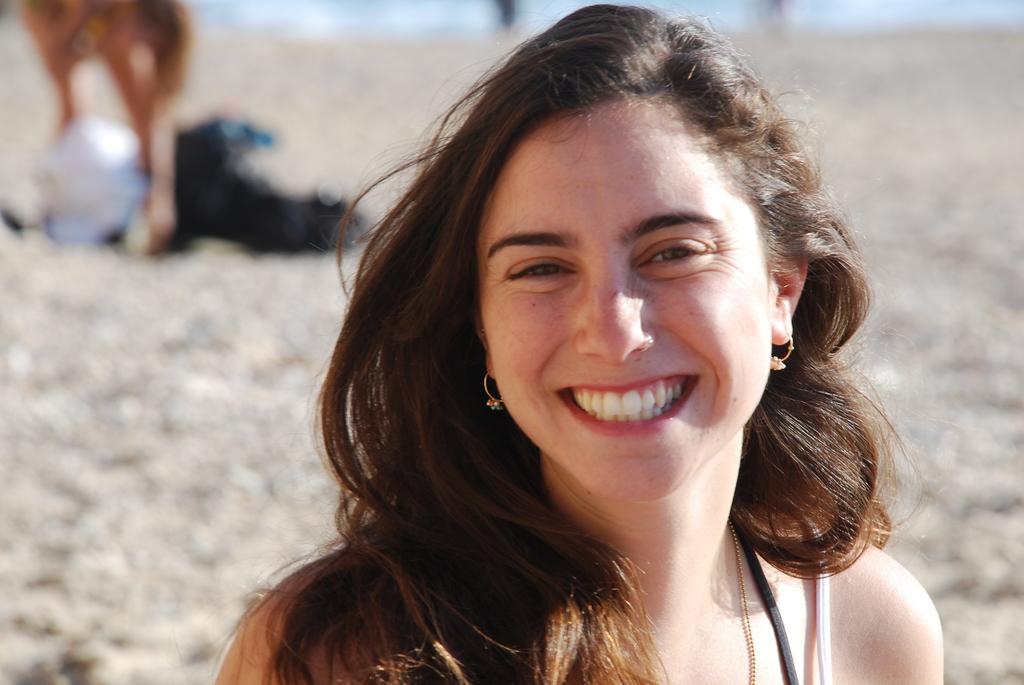Could you give a brief overview of what you see in this image? In this image I see a woman who is smiling and I see that it is totally blurred in the background. 